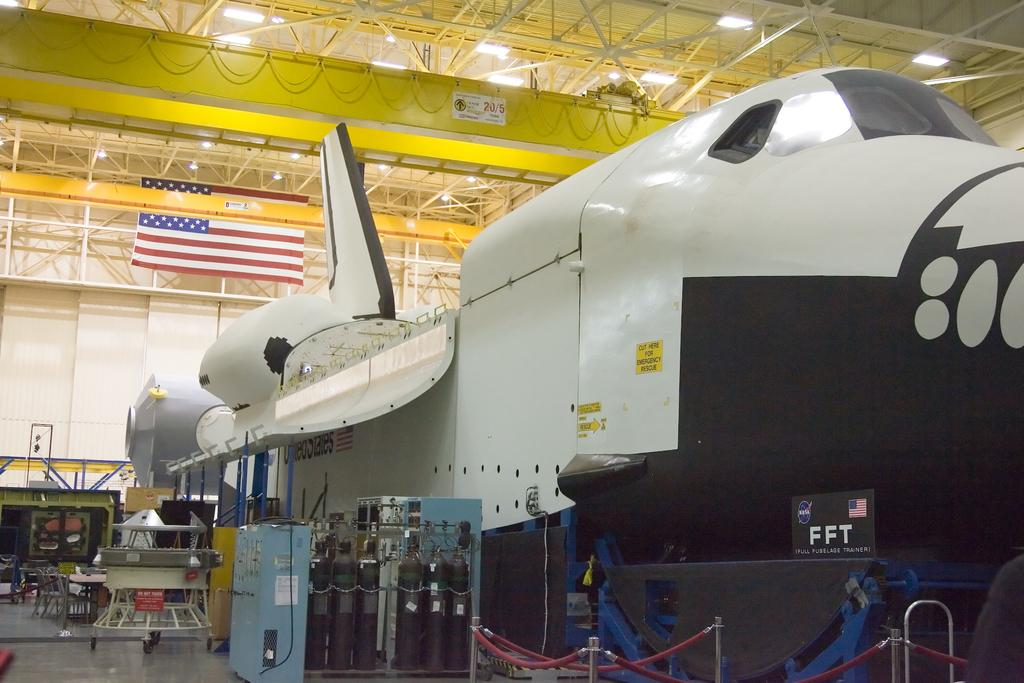<image>
Create a compact narrative representing the image presented. A space shuttle with a yellow sign that says cut sign in emergency is in a hangar. 